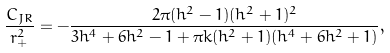Convert formula to latex. <formula><loc_0><loc_0><loc_500><loc_500>\frac { C _ { J R } } { r _ { + } ^ { 2 } } = - \frac { 2 \pi ( h ^ { 2 } - 1 ) ( h ^ { 2 } + 1 ) ^ { 2 } } { 3 h ^ { 4 } + 6 h ^ { 2 } - 1 + \pi k ( h ^ { 2 } + 1 ) ( h ^ { 4 } + 6 h ^ { 2 } + 1 ) } ,</formula> 